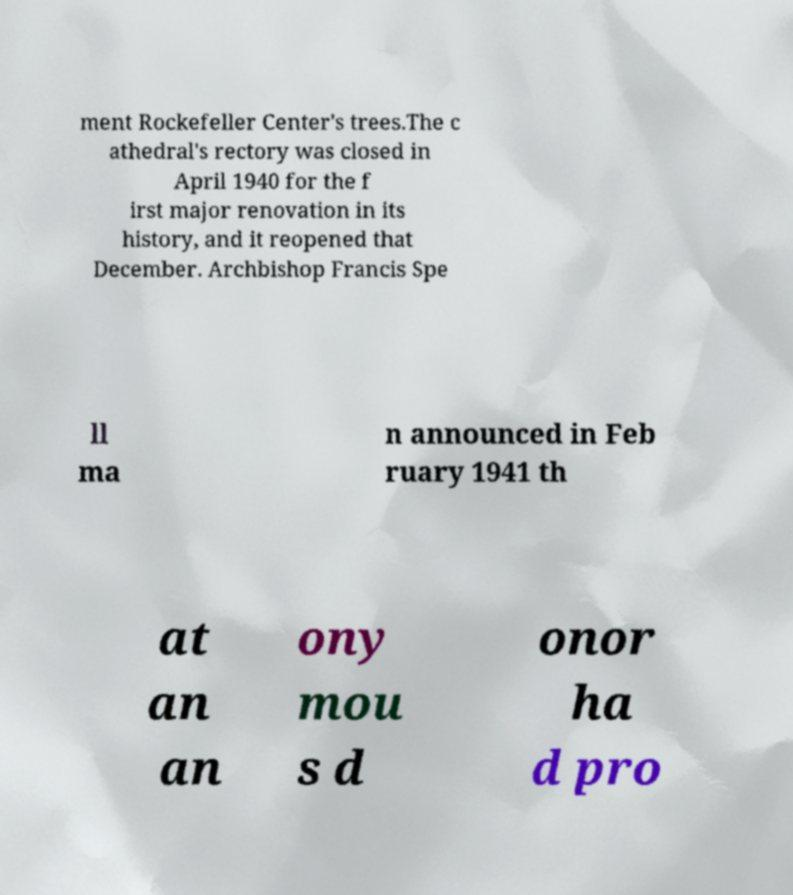There's text embedded in this image that I need extracted. Can you transcribe it verbatim? ment Rockefeller Center's trees.The c athedral's rectory was closed in April 1940 for the f irst major renovation in its history, and it reopened that December. Archbishop Francis Spe ll ma n announced in Feb ruary 1941 th at an an ony mou s d onor ha d pro 